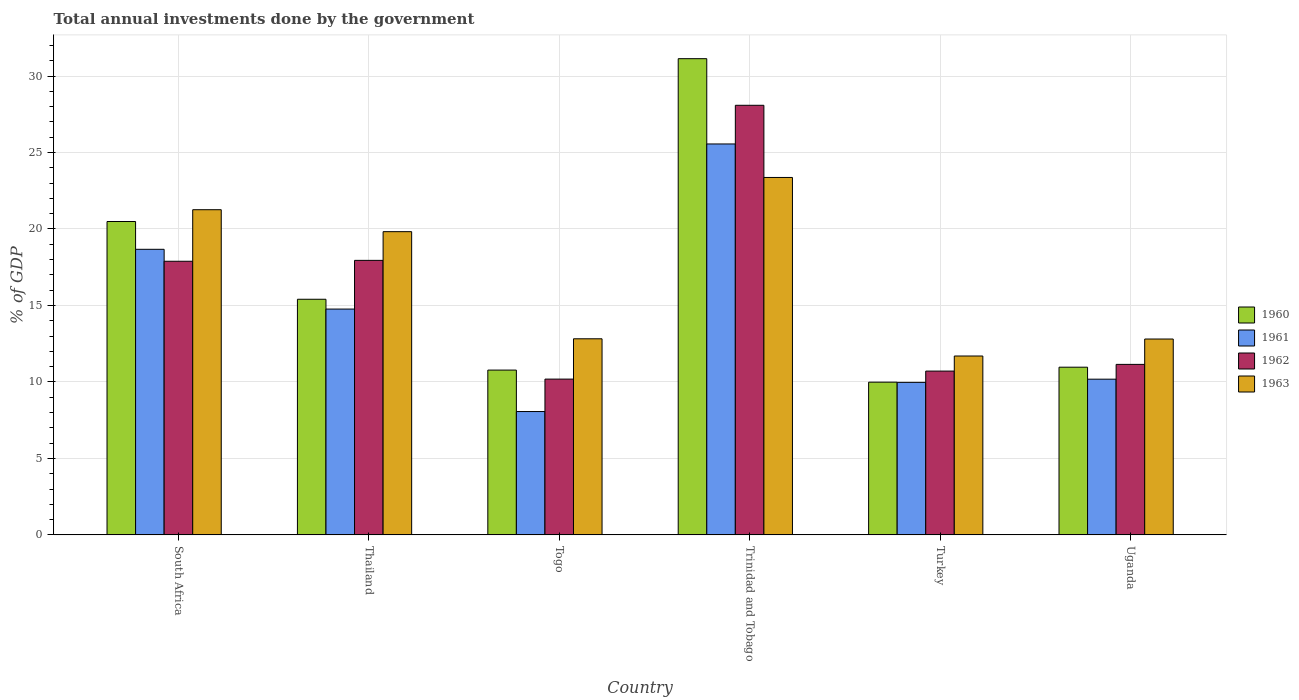How many groups of bars are there?
Your answer should be very brief. 6. Are the number of bars on each tick of the X-axis equal?
Make the answer very short. Yes. How many bars are there on the 2nd tick from the left?
Make the answer very short. 4. How many bars are there on the 3rd tick from the right?
Offer a very short reply. 4. What is the label of the 3rd group of bars from the left?
Make the answer very short. Togo. In how many cases, is the number of bars for a given country not equal to the number of legend labels?
Your answer should be compact. 0. What is the total annual investments done by the government in 1961 in South Africa?
Your response must be concise. 18.67. Across all countries, what is the maximum total annual investments done by the government in 1962?
Make the answer very short. 28.09. Across all countries, what is the minimum total annual investments done by the government in 1961?
Your response must be concise. 8.06. In which country was the total annual investments done by the government in 1962 maximum?
Ensure brevity in your answer.  Trinidad and Tobago. What is the total total annual investments done by the government in 1960 in the graph?
Your answer should be compact. 98.75. What is the difference between the total annual investments done by the government in 1960 in South Africa and that in Uganda?
Make the answer very short. 9.52. What is the difference between the total annual investments done by the government in 1960 in South Africa and the total annual investments done by the government in 1962 in Trinidad and Tobago?
Ensure brevity in your answer.  -7.6. What is the average total annual investments done by the government in 1963 per country?
Your answer should be compact. 16.96. What is the difference between the total annual investments done by the government of/in 1961 and total annual investments done by the government of/in 1962 in Togo?
Ensure brevity in your answer.  -2.12. In how many countries, is the total annual investments done by the government in 1962 greater than 2 %?
Your answer should be very brief. 6. What is the ratio of the total annual investments done by the government in 1963 in Thailand to that in Turkey?
Provide a succinct answer. 1.7. Is the total annual investments done by the government in 1962 in South Africa less than that in Turkey?
Your answer should be compact. No. What is the difference between the highest and the second highest total annual investments done by the government in 1963?
Give a very brief answer. -1.44. What is the difference between the highest and the lowest total annual investments done by the government in 1961?
Your answer should be compact. 17.49. In how many countries, is the total annual investments done by the government in 1963 greater than the average total annual investments done by the government in 1963 taken over all countries?
Keep it short and to the point. 3. Is the sum of the total annual investments done by the government in 1963 in Togo and Trinidad and Tobago greater than the maximum total annual investments done by the government in 1961 across all countries?
Your response must be concise. Yes. Is it the case that in every country, the sum of the total annual investments done by the government in 1961 and total annual investments done by the government in 1963 is greater than the sum of total annual investments done by the government in 1962 and total annual investments done by the government in 1960?
Provide a succinct answer. No. What does the 1st bar from the right in Trinidad and Tobago represents?
Your response must be concise. 1963. Is it the case that in every country, the sum of the total annual investments done by the government in 1963 and total annual investments done by the government in 1960 is greater than the total annual investments done by the government in 1962?
Give a very brief answer. Yes. How many bars are there?
Your response must be concise. 24. What is the difference between two consecutive major ticks on the Y-axis?
Your response must be concise. 5. Does the graph contain any zero values?
Keep it short and to the point. No. Does the graph contain grids?
Provide a short and direct response. Yes. Where does the legend appear in the graph?
Provide a short and direct response. Center right. How are the legend labels stacked?
Your answer should be compact. Vertical. What is the title of the graph?
Your response must be concise. Total annual investments done by the government. Does "1997" appear as one of the legend labels in the graph?
Provide a succinct answer. No. What is the label or title of the X-axis?
Your response must be concise. Country. What is the label or title of the Y-axis?
Offer a very short reply. % of GDP. What is the % of GDP in 1960 in South Africa?
Ensure brevity in your answer.  20.49. What is the % of GDP in 1961 in South Africa?
Your answer should be compact. 18.67. What is the % of GDP of 1962 in South Africa?
Make the answer very short. 17.89. What is the % of GDP of 1963 in South Africa?
Give a very brief answer. 21.26. What is the % of GDP of 1960 in Thailand?
Ensure brevity in your answer.  15.41. What is the % of GDP of 1961 in Thailand?
Ensure brevity in your answer.  14.76. What is the % of GDP of 1962 in Thailand?
Your answer should be compact. 17.95. What is the % of GDP of 1963 in Thailand?
Offer a terse response. 19.82. What is the % of GDP in 1960 in Togo?
Provide a succinct answer. 10.77. What is the % of GDP of 1961 in Togo?
Provide a short and direct response. 8.06. What is the % of GDP of 1962 in Togo?
Your response must be concise. 10.19. What is the % of GDP in 1963 in Togo?
Ensure brevity in your answer.  12.82. What is the % of GDP in 1960 in Trinidad and Tobago?
Provide a short and direct response. 31.13. What is the % of GDP of 1961 in Trinidad and Tobago?
Provide a short and direct response. 25.56. What is the % of GDP in 1962 in Trinidad and Tobago?
Your response must be concise. 28.09. What is the % of GDP of 1963 in Trinidad and Tobago?
Offer a terse response. 23.37. What is the % of GDP in 1960 in Turkey?
Keep it short and to the point. 9.99. What is the % of GDP in 1961 in Turkey?
Provide a short and direct response. 9.97. What is the % of GDP in 1962 in Turkey?
Your answer should be very brief. 10.71. What is the % of GDP in 1963 in Turkey?
Offer a very short reply. 11.7. What is the % of GDP of 1960 in Uganda?
Offer a very short reply. 10.96. What is the % of GDP of 1961 in Uganda?
Your response must be concise. 10.18. What is the % of GDP of 1962 in Uganda?
Give a very brief answer. 11.15. What is the % of GDP in 1963 in Uganda?
Give a very brief answer. 12.81. Across all countries, what is the maximum % of GDP in 1960?
Offer a very short reply. 31.13. Across all countries, what is the maximum % of GDP in 1961?
Your answer should be very brief. 25.56. Across all countries, what is the maximum % of GDP of 1962?
Keep it short and to the point. 28.09. Across all countries, what is the maximum % of GDP of 1963?
Keep it short and to the point. 23.37. Across all countries, what is the minimum % of GDP in 1960?
Offer a terse response. 9.99. Across all countries, what is the minimum % of GDP in 1961?
Offer a terse response. 8.06. Across all countries, what is the minimum % of GDP of 1962?
Your response must be concise. 10.19. Across all countries, what is the minimum % of GDP in 1963?
Provide a short and direct response. 11.7. What is the total % of GDP in 1960 in the graph?
Provide a short and direct response. 98.75. What is the total % of GDP of 1961 in the graph?
Your answer should be very brief. 87.21. What is the total % of GDP in 1962 in the graph?
Ensure brevity in your answer.  95.97. What is the total % of GDP of 1963 in the graph?
Your answer should be very brief. 101.77. What is the difference between the % of GDP of 1960 in South Africa and that in Thailand?
Ensure brevity in your answer.  5.08. What is the difference between the % of GDP in 1961 in South Africa and that in Thailand?
Provide a short and direct response. 3.91. What is the difference between the % of GDP of 1962 in South Africa and that in Thailand?
Offer a very short reply. -0.06. What is the difference between the % of GDP of 1963 in South Africa and that in Thailand?
Ensure brevity in your answer.  1.44. What is the difference between the % of GDP in 1960 in South Africa and that in Togo?
Provide a succinct answer. 9.71. What is the difference between the % of GDP of 1961 in South Africa and that in Togo?
Make the answer very short. 10.61. What is the difference between the % of GDP in 1962 in South Africa and that in Togo?
Keep it short and to the point. 7.7. What is the difference between the % of GDP of 1963 in South Africa and that in Togo?
Your answer should be compact. 8.44. What is the difference between the % of GDP in 1960 in South Africa and that in Trinidad and Tobago?
Keep it short and to the point. -10.64. What is the difference between the % of GDP in 1961 in South Africa and that in Trinidad and Tobago?
Provide a short and direct response. -6.89. What is the difference between the % of GDP of 1962 in South Africa and that in Trinidad and Tobago?
Your answer should be very brief. -10.2. What is the difference between the % of GDP in 1963 in South Africa and that in Trinidad and Tobago?
Ensure brevity in your answer.  -2.11. What is the difference between the % of GDP in 1960 in South Africa and that in Turkey?
Ensure brevity in your answer.  10.5. What is the difference between the % of GDP of 1961 in South Africa and that in Turkey?
Your response must be concise. 8.7. What is the difference between the % of GDP in 1962 in South Africa and that in Turkey?
Provide a short and direct response. 7.18. What is the difference between the % of GDP in 1963 in South Africa and that in Turkey?
Your answer should be compact. 9.56. What is the difference between the % of GDP of 1960 in South Africa and that in Uganda?
Offer a very short reply. 9.52. What is the difference between the % of GDP of 1961 in South Africa and that in Uganda?
Ensure brevity in your answer.  8.49. What is the difference between the % of GDP of 1962 in South Africa and that in Uganda?
Your answer should be very brief. 6.74. What is the difference between the % of GDP in 1963 in South Africa and that in Uganda?
Keep it short and to the point. 8.45. What is the difference between the % of GDP in 1960 in Thailand and that in Togo?
Give a very brief answer. 4.63. What is the difference between the % of GDP of 1961 in Thailand and that in Togo?
Give a very brief answer. 6.7. What is the difference between the % of GDP of 1962 in Thailand and that in Togo?
Provide a succinct answer. 7.76. What is the difference between the % of GDP in 1963 in Thailand and that in Togo?
Provide a succinct answer. 7. What is the difference between the % of GDP in 1960 in Thailand and that in Trinidad and Tobago?
Offer a very short reply. -15.73. What is the difference between the % of GDP in 1961 in Thailand and that in Trinidad and Tobago?
Offer a terse response. -10.79. What is the difference between the % of GDP in 1962 in Thailand and that in Trinidad and Tobago?
Offer a very short reply. -10.14. What is the difference between the % of GDP in 1963 in Thailand and that in Trinidad and Tobago?
Provide a succinct answer. -3.54. What is the difference between the % of GDP in 1960 in Thailand and that in Turkey?
Give a very brief answer. 5.42. What is the difference between the % of GDP of 1961 in Thailand and that in Turkey?
Provide a short and direct response. 4.79. What is the difference between the % of GDP in 1962 in Thailand and that in Turkey?
Your answer should be very brief. 7.24. What is the difference between the % of GDP of 1963 in Thailand and that in Turkey?
Offer a very short reply. 8.13. What is the difference between the % of GDP in 1960 in Thailand and that in Uganda?
Offer a terse response. 4.44. What is the difference between the % of GDP in 1961 in Thailand and that in Uganda?
Your response must be concise. 4.58. What is the difference between the % of GDP in 1963 in Thailand and that in Uganda?
Offer a very short reply. 7.02. What is the difference between the % of GDP in 1960 in Togo and that in Trinidad and Tobago?
Provide a short and direct response. -20.36. What is the difference between the % of GDP of 1961 in Togo and that in Trinidad and Tobago?
Provide a succinct answer. -17.49. What is the difference between the % of GDP in 1962 in Togo and that in Trinidad and Tobago?
Keep it short and to the point. -17.9. What is the difference between the % of GDP of 1963 in Togo and that in Trinidad and Tobago?
Ensure brevity in your answer.  -10.55. What is the difference between the % of GDP in 1960 in Togo and that in Turkey?
Keep it short and to the point. 0.79. What is the difference between the % of GDP of 1961 in Togo and that in Turkey?
Your answer should be very brief. -1.91. What is the difference between the % of GDP in 1962 in Togo and that in Turkey?
Your response must be concise. -0.52. What is the difference between the % of GDP of 1963 in Togo and that in Turkey?
Your answer should be compact. 1.13. What is the difference between the % of GDP in 1960 in Togo and that in Uganda?
Your answer should be compact. -0.19. What is the difference between the % of GDP of 1961 in Togo and that in Uganda?
Offer a very short reply. -2.12. What is the difference between the % of GDP in 1962 in Togo and that in Uganda?
Give a very brief answer. -0.96. What is the difference between the % of GDP in 1963 in Togo and that in Uganda?
Provide a short and direct response. 0.01. What is the difference between the % of GDP of 1960 in Trinidad and Tobago and that in Turkey?
Ensure brevity in your answer.  21.15. What is the difference between the % of GDP of 1961 in Trinidad and Tobago and that in Turkey?
Offer a terse response. 15.59. What is the difference between the % of GDP of 1962 in Trinidad and Tobago and that in Turkey?
Offer a terse response. 17.38. What is the difference between the % of GDP of 1963 in Trinidad and Tobago and that in Turkey?
Provide a succinct answer. 11.67. What is the difference between the % of GDP in 1960 in Trinidad and Tobago and that in Uganda?
Keep it short and to the point. 20.17. What is the difference between the % of GDP of 1961 in Trinidad and Tobago and that in Uganda?
Your answer should be very brief. 15.38. What is the difference between the % of GDP in 1962 in Trinidad and Tobago and that in Uganda?
Your answer should be compact. 16.94. What is the difference between the % of GDP in 1963 in Trinidad and Tobago and that in Uganda?
Provide a short and direct response. 10.56. What is the difference between the % of GDP in 1960 in Turkey and that in Uganda?
Make the answer very short. -0.98. What is the difference between the % of GDP in 1961 in Turkey and that in Uganda?
Offer a terse response. -0.21. What is the difference between the % of GDP of 1962 in Turkey and that in Uganda?
Provide a succinct answer. -0.44. What is the difference between the % of GDP of 1963 in Turkey and that in Uganda?
Keep it short and to the point. -1.11. What is the difference between the % of GDP of 1960 in South Africa and the % of GDP of 1961 in Thailand?
Provide a succinct answer. 5.73. What is the difference between the % of GDP in 1960 in South Africa and the % of GDP in 1962 in Thailand?
Make the answer very short. 2.54. What is the difference between the % of GDP of 1960 in South Africa and the % of GDP of 1963 in Thailand?
Provide a short and direct response. 0.66. What is the difference between the % of GDP of 1961 in South Africa and the % of GDP of 1962 in Thailand?
Give a very brief answer. 0.72. What is the difference between the % of GDP of 1961 in South Africa and the % of GDP of 1963 in Thailand?
Your response must be concise. -1.15. What is the difference between the % of GDP in 1962 in South Africa and the % of GDP in 1963 in Thailand?
Keep it short and to the point. -1.94. What is the difference between the % of GDP of 1960 in South Africa and the % of GDP of 1961 in Togo?
Offer a very short reply. 12.42. What is the difference between the % of GDP in 1960 in South Africa and the % of GDP in 1962 in Togo?
Offer a terse response. 10.3. What is the difference between the % of GDP in 1960 in South Africa and the % of GDP in 1963 in Togo?
Keep it short and to the point. 7.67. What is the difference between the % of GDP of 1961 in South Africa and the % of GDP of 1962 in Togo?
Your answer should be compact. 8.49. What is the difference between the % of GDP of 1961 in South Africa and the % of GDP of 1963 in Togo?
Your answer should be very brief. 5.85. What is the difference between the % of GDP of 1962 in South Africa and the % of GDP of 1963 in Togo?
Make the answer very short. 5.07. What is the difference between the % of GDP of 1960 in South Africa and the % of GDP of 1961 in Trinidad and Tobago?
Offer a very short reply. -5.07. What is the difference between the % of GDP of 1960 in South Africa and the % of GDP of 1962 in Trinidad and Tobago?
Offer a very short reply. -7.6. What is the difference between the % of GDP of 1960 in South Africa and the % of GDP of 1963 in Trinidad and Tobago?
Keep it short and to the point. -2.88. What is the difference between the % of GDP in 1961 in South Africa and the % of GDP in 1962 in Trinidad and Tobago?
Keep it short and to the point. -9.42. What is the difference between the % of GDP of 1961 in South Africa and the % of GDP of 1963 in Trinidad and Tobago?
Give a very brief answer. -4.7. What is the difference between the % of GDP of 1962 in South Africa and the % of GDP of 1963 in Trinidad and Tobago?
Make the answer very short. -5.48. What is the difference between the % of GDP of 1960 in South Africa and the % of GDP of 1961 in Turkey?
Offer a very short reply. 10.52. What is the difference between the % of GDP in 1960 in South Africa and the % of GDP in 1962 in Turkey?
Offer a terse response. 9.78. What is the difference between the % of GDP of 1960 in South Africa and the % of GDP of 1963 in Turkey?
Give a very brief answer. 8.79. What is the difference between the % of GDP of 1961 in South Africa and the % of GDP of 1962 in Turkey?
Keep it short and to the point. 7.96. What is the difference between the % of GDP in 1961 in South Africa and the % of GDP in 1963 in Turkey?
Your answer should be compact. 6.98. What is the difference between the % of GDP of 1962 in South Africa and the % of GDP of 1963 in Turkey?
Offer a terse response. 6.19. What is the difference between the % of GDP of 1960 in South Africa and the % of GDP of 1961 in Uganda?
Keep it short and to the point. 10.31. What is the difference between the % of GDP of 1960 in South Africa and the % of GDP of 1962 in Uganda?
Give a very brief answer. 9.34. What is the difference between the % of GDP in 1960 in South Africa and the % of GDP in 1963 in Uganda?
Make the answer very short. 7.68. What is the difference between the % of GDP of 1961 in South Africa and the % of GDP of 1962 in Uganda?
Provide a short and direct response. 7.52. What is the difference between the % of GDP of 1961 in South Africa and the % of GDP of 1963 in Uganda?
Keep it short and to the point. 5.87. What is the difference between the % of GDP in 1962 in South Africa and the % of GDP in 1963 in Uganda?
Your answer should be very brief. 5.08. What is the difference between the % of GDP in 1960 in Thailand and the % of GDP in 1961 in Togo?
Your answer should be very brief. 7.34. What is the difference between the % of GDP in 1960 in Thailand and the % of GDP in 1962 in Togo?
Provide a short and direct response. 5.22. What is the difference between the % of GDP of 1960 in Thailand and the % of GDP of 1963 in Togo?
Your answer should be compact. 2.58. What is the difference between the % of GDP of 1961 in Thailand and the % of GDP of 1962 in Togo?
Offer a terse response. 4.58. What is the difference between the % of GDP of 1961 in Thailand and the % of GDP of 1963 in Togo?
Offer a very short reply. 1.94. What is the difference between the % of GDP in 1962 in Thailand and the % of GDP in 1963 in Togo?
Provide a short and direct response. 5.13. What is the difference between the % of GDP of 1960 in Thailand and the % of GDP of 1961 in Trinidad and Tobago?
Provide a succinct answer. -10.15. What is the difference between the % of GDP in 1960 in Thailand and the % of GDP in 1962 in Trinidad and Tobago?
Your response must be concise. -12.68. What is the difference between the % of GDP of 1960 in Thailand and the % of GDP of 1963 in Trinidad and Tobago?
Your answer should be compact. -7.96. What is the difference between the % of GDP in 1961 in Thailand and the % of GDP in 1962 in Trinidad and Tobago?
Keep it short and to the point. -13.32. What is the difference between the % of GDP in 1961 in Thailand and the % of GDP in 1963 in Trinidad and Tobago?
Provide a short and direct response. -8.6. What is the difference between the % of GDP of 1962 in Thailand and the % of GDP of 1963 in Trinidad and Tobago?
Provide a succinct answer. -5.42. What is the difference between the % of GDP of 1960 in Thailand and the % of GDP of 1961 in Turkey?
Keep it short and to the point. 5.43. What is the difference between the % of GDP in 1960 in Thailand and the % of GDP in 1962 in Turkey?
Ensure brevity in your answer.  4.7. What is the difference between the % of GDP of 1960 in Thailand and the % of GDP of 1963 in Turkey?
Offer a terse response. 3.71. What is the difference between the % of GDP of 1961 in Thailand and the % of GDP of 1962 in Turkey?
Offer a very short reply. 4.05. What is the difference between the % of GDP of 1961 in Thailand and the % of GDP of 1963 in Turkey?
Your answer should be compact. 3.07. What is the difference between the % of GDP of 1962 in Thailand and the % of GDP of 1963 in Turkey?
Your response must be concise. 6.25. What is the difference between the % of GDP in 1960 in Thailand and the % of GDP in 1961 in Uganda?
Your response must be concise. 5.23. What is the difference between the % of GDP of 1960 in Thailand and the % of GDP of 1962 in Uganda?
Offer a terse response. 4.26. What is the difference between the % of GDP in 1961 in Thailand and the % of GDP in 1962 in Uganda?
Offer a very short reply. 3.62. What is the difference between the % of GDP of 1961 in Thailand and the % of GDP of 1963 in Uganda?
Your response must be concise. 1.96. What is the difference between the % of GDP of 1962 in Thailand and the % of GDP of 1963 in Uganda?
Keep it short and to the point. 5.14. What is the difference between the % of GDP of 1960 in Togo and the % of GDP of 1961 in Trinidad and Tobago?
Offer a terse response. -14.78. What is the difference between the % of GDP of 1960 in Togo and the % of GDP of 1962 in Trinidad and Tobago?
Your answer should be compact. -17.31. What is the difference between the % of GDP in 1960 in Togo and the % of GDP in 1963 in Trinidad and Tobago?
Your answer should be very brief. -12.59. What is the difference between the % of GDP in 1961 in Togo and the % of GDP in 1962 in Trinidad and Tobago?
Offer a terse response. -20.02. What is the difference between the % of GDP of 1961 in Togo and the % of GDP of 1963 in Trinidad and Tobago?
Your answer should be very brief. -15.3. What is the difference between the % of GDP of 1962 in Togo and the % of GDP of 1963 in Trinidad and Tobago?
Give a very brief answer. -13.18. What is the difference between the % of GDP of 1960 in Togo and the % of GDP of 1961 in Turkey?
Provide a succinct answer. 0.8. What is the difference between the % of GDP in 1960 in Togo and the % of GDP in 1962 in Turkey?
Your answer should be compact. 0.06. What is the difference between the % of GDP of 1960 in Togo and the % of GDP of 1963 in Turkey?
Your answer should be very brief. -0.92. What is the difference between the % of GDP of 1961 in Togo and the % of GDP of 1962 in Turkey?
Provide a short and direct response. -2.65. What is the difference between the % of GDP in 1961 in Togo and the % of GDP in 1963 in Turkey?
Ensure brevity in your answer.  -3.63. What is the difference between the % of GDP of 1962 in Togo and the % of GDP of 1963 in Turkey?
Offer a terse response. -1.51. What is the difference between the % of GDP of 1960 in Togo and the % of GDP of 1961 in Uganda?
Make the answer very short. 0.59. What is the difference between the % of GDP in 1960 in Togo and the % of GDP in 1962 in Uganda?
Give a very brief answer. -0.37. What is the difference between the % of GDP in 1960 in Togo and the % of GDP in 1963 in Uganda?
Make the answer very short. -2.03. What is the difference between the % of GDP of 1961 in Togo and the % of GDP of 1962 in Uganda?
Your answer should be very brief. -3.08. What is the difference between the % of GDP of 1961 in Togo and the % of GDP of 1963 in Uganda?
Offer a very short reply. -4.74. What is the difference between the % of GDP in 1962 in Togo and the % of GDP in 1963 in Uganda?
Make the answer very short. -2.62. What is the difference between the % of GDP in 1960 in Trinidad and Tobago and the % of GDP in 1961 in Turkey?
Provide a short and direct response. 21.16. What is the difference between the % of GDP in 1960 in Trinidad and Tobago and the % of GDP in 1962 in Turkey?
Keep it short and to the point. 20.42. What is the difference between the % of GDP of 1960 in Trinidad and Tobago and the % of GDP of 1963 in Turkey?
Offer a terse response. 19.44. What is the difference between the % of GDP in 1961 in Trinidad and Tobago and the % of GDP in 1962 in Turkey?
Your response must be concise. 14.85. What is the difference between the % of GDP of 1961 in Trinidad and Tobago and the % of GDP of 1963 in Turkey?
Provide a short and direct response. 13.86. What is the difference between the % of GDP in 1962 in Trinidad and Tobago and the % of GDP in 1963 in Turkey?
Provide a succinct answer. 16.39. What is the difference between the % of GDP in 1960 in Trinidad and Tobago and the % of GDP in 1961 in Uganda?
Keep it short and to the point. 20.95. What is the difference between the % of GDP in 1960 in Trinidad and Tobago and the % of GDP in 1962 in Uganda?
Keep it short and to the point. 19.99. What is the difference between the % of GDP of 1960 in Trinidad and Tobago and the % of GDP of 1963 in Uganda?
Your answer should be compact. 18.33. What is the difference between the % of GDP in 1961 in Trinidad and Tobago and the % of GDP in 1962 in Uganda?
Give a very brief answer. 14.41. What is the difference between the % of GDP of 1961 in Trinidad and Tobago and the % of GDP of 1963 in Uganda?
Offer a terse response. 12.75. What is the difference between the % of GDP in 1962 in Trinidad and Tobago and the % of GDP in 1963 in Uganda?
Provide a short and direct response. 15.28. What is the difference between the % of GDP of 1960 in Turkey and the % of GDP of 1961 in Uganda?
Offer a very short reply. -0.2. What is the difference between the % of GDP in 1960 in Turkey and the % of GDP in 1962 in Uganda?
Give a very brief answer. -1.16. What is the difference between the % of GDP of 1960 in Turkey and the % of GDP of 1963 in Uganda?
Provide a succinct answer. -2.82. What is the difference between the % of GDP of 1961 in Turkey and the % of GDP of 1962 in Uganda?
Offer a terse response. -1.18. What is the difference between the % of GDP of 1961 in Turkey and the % of GDP of 1963 in Uganda?
Your response must be concise. -2.83. What is the difference between the % of GDP in 1962 in Turkey and the % of GDP in 1963 in Uganda?
Provide a succinct answer. -2.1. What is the average % of GDP in 1960 per country?
Make the answer very short. 16.46. What is the average % of GDP of 1961 per country?
Your response must be concise. 14.54. What is the average % of GDP of 1962 per country?
Ensure brevity in your answer.  15.99. What is the average % of GDP in 1963 per country?
Offer a terse response. 16.96. What is the difference between the % of GDP of 1960 and % of GDP of 1961 in South Africa?
Your answer should be compact. 1.82. What is the difference between the % of GDP of 1960 and % of GDP of 1962 in South Africa?
Give a very brief answer. 2.6. What is the difference between the % of GDP in 1960 and % of GDP in 1963 in South Africa?
Your response must be concise. -0.77. What is the difference between the % of GDP in 1961 and % of GDP in 1962 in South Africa?
Keep it short and to the point. 0.78. What is the difference between the % of GDP in 1961 and % of GDP in 1963 in South Africa?
Offer a very short reply. -2.59. What is the difference between the % of GDP of 1962 and % of GDP of 1963 in South Africa?
Provide a short and direct response. -3.37. What is the difference between the % of GDP of 1960 and % of GDP of 1961 in Thailand?
Provide a succinct answer. 0.64. What is the difference between the % of GDP in 1960 and % of GDP in 1962 in Thailand?
Ensure brevity in your answer.  -2.54. What is the difference between the % of GDP in 1960 and % of GDP in 1963 in Thailand?
Ensure brevity in your answer.  -4.42. What is the difference between the % of GDP of 1961 and % of GDP of 1962 in Thailand?
Offer a terse response. -3.18. What is the difference between the % of GDP of 1961 and % of GDP of 1963 in Thailand?
Keep it short and to the point. -5.06. What is the difference between the % of GDP in 1962 and % of GDP in 1963 in Thailand?
Your answer should be compact. -1.88. What is the difference between the % of GDP in 1960 and % of GDP in 1961 in Togo?
Your answer should be very brief. 2.71. What is the difference between the % of GDP in 1960 and % of GDP in 1962 in Togo?
Make the answer very short. 0.59. What is the difference between the % of GDP of 1960 and % of GDP of 1963 in Togo?
Offer a very short reply. -2.05. What is the difference between the % of GDP of 1961 and % of GDP of 1962 in Togo?
Make the answer very short. -2.12. What is the difference between the % of GDP of 1961 and % of GDP of 1963 in Togo?
Your answer should be very brief. -4.76. What is the difference between the % of GDP in 1962 and % of GDP in 1963 in Togo?
Your answer should be very brief. -2.64. What is the difference between the % of GDP in 1960 and % of GDP in 1961 in Trinidad and Tobago?
Make the answer very short. 5.58. What is the difference between the % of GDP in 1960 and % of GDP in 1962 in Trinidad and Tobago?
Make the answer very short. 3.05. What is the difference between the % of GDP in 1960 and % of GDP in 1963 in Trinidad and Tobago?
Offer a very short reply. 7.77. What is the difference between the % of GDP of 1961 and % of GDP of 1962 in Trinidad and Tobago?
Offer a very short reply. -2.53. What is the difference between the % of GDP of 1961 and % of GDP of 1963 in Trinidad and Tobago?
Your answer should be very brief. 2.19. What is the difference between the % of GDP of 1962 and % of GDP of 1963 in Trinidad and Tobago?
Your answer should be very brief. 4.72. What is the difference between the % of GDP of 1960 and % of GDP of 1961 in Turkey?
Ensure brevity in your answer.  0.01. What is the difference between the % of GDP in 1960 and % of GDP in 1962 in Turkey?
Provide a short and direct response. -0.72. What is the difference between the % of GDP of 1960 and % of GDP of 1963 in Turkey?
Give a very brief answer. -1.71. What is the difference between the % of GDP of 1961 and % of GDP of 1962 in Turkey?
Keep it short and to the point. -0.74. What is the difference between the % of GDP in 1961 and % of GDP in 1963 in Turkey?
Your response must be concise. -1.72. What is the difference between the % of GDP of 1962 and % of GDP of 1963 in Turkey?
Give a very brief answer. -0.99. What is the difference between the % of GDP in 1960 and % of GDP in 1961 in Uganda?
Provide a short and direct response. 0.78. What is the difference between the % of GDP in 1960 and % of GDP in 1962 in Uganda?
Offer a very short reply. -0.18. What is the difference between the % of GDP of 1960 and % of GDP of 1963 in Uganda?
Your answer should be very brief. -1.84. What is the difference between the % of GDP of 1961 and % of GDP of 1962 in Uganda?
Your answer should be very brief. -0.97. What is the difference between the % of GDP in 1961 and % of GDP in 1963 in Uganda?
Your response must be concise. -2.63. What is the difference between the % of GDP in 1962 and % of GDP in 1963 in Uganda?
Your answer should be compact. -1.66. What is the ratio of the % of GDP of 1960 in South Africa to that in Thailand?
Keep it short and to the point. 1.33. What is the ratio of the % of GDP of 1961 in South Africa to that in Thailand?
Provide a succinct answer. 1.26. What is the ratio of the % of GDP in 1962 in South Africa to that in Thailand?
Provide a short and direct response. 1. What is the ratio of the % of GDP in 1963 in South Africa to that in Thailand?
Your answer should be compact. 1.07. What is the ratio of the % of GDP in 1960 in South Africa to that in Togo?
Give a very brief answer. 1.9. What is the ratio of the % of GDP in 1961 in South Africa to that in Togo?
Offer a very short reply. 2.32. What is the ratio of the % of GDP of 1962 in South Africa to that in Togo?
Give a very brief answer. 1.76. What is the ratio of the % of GDP in 1963 in South Africa to that in Togo?
Make the answer very short. 1.66. What is the ratio of the % of GDP of 1960 in South Africa to that in Trinidad and Tobago?
Make the answer very short. 0.66. What is the ratio of the % of GDP of 1961 in South Africa to that in Trinidad and Tobago?
Provide a succinct answer. 0.73. What is the ratio of the % of GDP in 1962 in South Africa to that in Trinidad and Tobago?
Keep it short and to the point. 0.64. What is the ratio of the % of GDP in 1963 in South Africa to that in Trinidad and Tobago?
Provide a short and direct response. 0.91. What is the ratio of the % of GDP in 1960 in South Africa to that in Turkey?
Your answer should be very brief. 2.05. What is the ratio of the % of GDP of 1961 in South Africa to that in Turkey?
Your answer should be very brief. 1.87. What is the ratio of the % of GDP of 1962 in South Africa to that in Turkey?
Ensure brevity in your answer.  1.67. What is the ratio of the % of GDP in 1963 in South Africa to that in Turkey?
Your response must be concise. 1.82. What is the ratio of the % of GDP of 1960 in South Africa to that in Uganda?
Keep it short and to the point. 1.87. What is the ratio of the % of GDP of 1961 in South Africa to that in Uganda?
Offer a very short reply. 1.83. What is the ratio of the % of GDP in 1962 in South Africa to that in Uganda?
Offer a terse response. 1.6. What is the ratio of the % of GDP in 1963 in South Africa to that in Uganda?
Offer a terse response. 1.66. What is the ratio of the % of GDP in 1960 in Thailand to that in Togo?
Your answer should be compact. 1.43. What is the ratio of the % of GDP of 1961 in Thailand to that in Togo?
Keep it short and to the point. 1.83. What is the ratio of the % of GDP of 1962 in Thailand to that in Togo?
Provide a short and direct response. 1.76. What is the ratio of the % of GDP of 1963 in Thailand to that in Togo?
Ensure brevity in your answer.  1.55. What is the ratio of the % of GDP of 1960 in Thailand to that in Trinidad and Tobago?
Offer a terse response. 0.49. What is the ratio of the % of GDP in 1961 in Thailand to that in Trinidad and Tobago?
Give a very brief answer. 0.58. What is the ratio of the % of GDP in 1962 in Thailand to that in Trinidad and Tobago?
Provide a short and direct response. 0.64. What is the ratio of the % of GDP in 1963 in Thailand to that in Trinidad and Tobago?
Offer a very short reply. 0.85. What is the ratio of the % of GDP of 1960 in Thailand to that in Turkey?
Your answer should be very brief. 1.54. What is the ratio of the % of GDP of 1961 in Thailand to that in Turkey?
Offer a terse response. 1.48. What is the ratio of the % of GDP of 1962 in Thailand to that in Turkey?
Keep it short and to the point. 1.68. What is the ratio of the % of GDP in 1963 in Thailand to that in Turkey?
Provide a succinct answer. 1.7. What is the ratio of the % of GDP in 1960 in Thailand to that in Uganda?
Your answer should be very brief. 1.41. What is the ratio of the % of GDP of 1961 in Thailand to that in Uganda?
Provide a succinct answer. 1.45. What is the ratio of the % of GDP of 1962 in Thailand to that in Uganda?
Provide a short and direct response. 1.61. What is the ratio of the % of GDP in 1963 in Thailand to that in Uganda?
Make the answer very short. 1.55. What is the ratio of the % of GDP in 1960 in Togo to that in Trinidad and Tobago?
Your response must be concise. 0.35. What is the ratio of the % of GDP of 1961 in Togo to that in Trinidad and Tobago?
Keep it short and to the point. 0.32. What is the ratio of the % of GDP of 1962 in Togo to that in Trinidad and Tobago?
Ensure brevity in your answer.  0.36. What is the ratio of the % of GDP in 1963 in Togo to that in Trinidad and Tobago?
Provide a short and direct response. 0.55. What is the ratio of the % of GDP in 1960 in Togo to that in Turkey?
Make the answer very short. 1.08. What is the ratio of the % of GDP of 1961 in Togo to that in Turkey?
Give a very brief answer. 0.81. What is the ratio of the % of GDP in 1962 in Togo to that in Turkey?
Keep it short and to the point. 0.95. What is the ratio of the % of GDP of 1963 in Togo to that in Turkey?
Make the answer very short. 1.1. What is the ratio of the % of GDP of 1960 in Togo to that in Uganda?
Provide a succinct answer. 0.98. What is the ratio of the % of GDP in 1961 in Togo to that in Uganda?
Your response must be concise. 0.79. What is the ratio of the % of GDP in 1962 in Togo to that in Uganda?
Your answer should be compact. 0.91. What is the ratio of the % of GDP in 1960 in Trinidad and Tobago to that in Turkey?
Offer a very short reply. 3.12. What is the ratio of the % of GDP of 1961 in Trinidad and Tobago to that in Turkey?
Give a very brief answer. 2.56. What is the ratio of the % of GDP in 1962 in Trinidad and Tobago to that in Turkey?
Give a very brief answer. 2.62. What is the ratio of the % of GDP of 1963 in Trinidad and Tobago to that in Turkey?
Your response must be concise. 2. What is the ratio of the % of GDP in 1960 in Trinidad and Tobago to that in Uganda?
Offer a terse response. 2.84. What is the ratio of the % of GDP in 1961 in Trinidad and Tobago to that in Uganda?
Offer a very short reply. 2.51. What is the ratio of the % of GDP in 1962 in Trinidad and Tobago to that in Uganda?
Ensure brevity in your answer.  2.52. What is the ratio of the % of GDP in 1963 in Trinidad and Tobago to that in Uganda?
Your answer should be compact. 1.82. What is the ratio of the % of GDP of 1960 in Turkey to that in Uganda?
Ensure brevity in your answer.  0.91. What is the ratio of the % of GDP in 1961 in Turkey to that in Uganda?
Ensure brevity in your answer.  0.98. What is the ratio of the % of GDP in 1962 in Turkey to that in Uganda?
Provide a short and direct response. 0.96. What is the ratio of the % of GDP in 1963 in Turkey to that in Uganda?
Offer a terse response. 0.91. What is the difference between the highest and the second highest % of GDP in 1960?
Provide a short and direct response. 10.64. What is the difference between the highest and the second highest % of GDP in 1961?
Your answer should be very brief. 6.89. What is the difference between the highest and the second highest % of GDP of 1962?
Give a very brief answer. 10.14. What is the difference between the highest and the second highest % of GDP in 1963?
Your answer should be compact. 2.11. What is the difference between the highest and the lowest % of GDP in 1960?
Offer a terse response. 21.15. What is the difference between the highest and the lowest % of GDP in 1961?
Provide a short and direct response. 17.49. What is the difference between the highest and the lowest % of GDP of 1962?
Offer a very short reply. 17.9. What is the difference between the highest and the lowest % of GDP in 1963?
Provide a short and direct response. 11.67. 